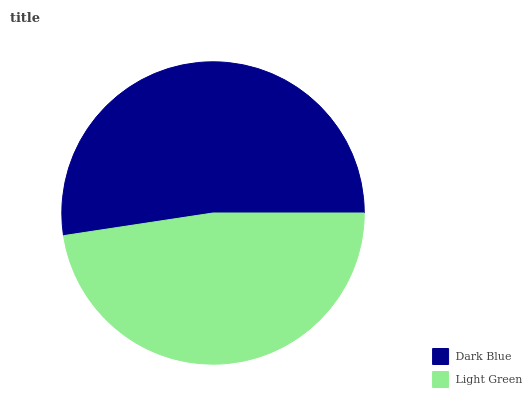Is Light Green the minimum?
Answer yes or no. Yes. Is Dark Blue the maximum?
Answer yes or no. Yes. Is Light Green the maximum?
Answer yes or no. No. Is Dark Blue greater than Light Green?
Answer yes or no. Yes. Is Light Green less than Dark Blue?
Answer yes or no. Yes. Is Light Green greater than Dark Blue?
Answer yes or no. No. Is Dark Blue less than Light Green?
Answer yes or no. No. Is Dark Blue the high median?
Answer yes or no. Yes. Is Light Green the low median?
Answer yes or no. Yes. Is Light Green the high median?
Answer yes or no. No. Is Dark Blue the low median?
Answer yes or no. No. 